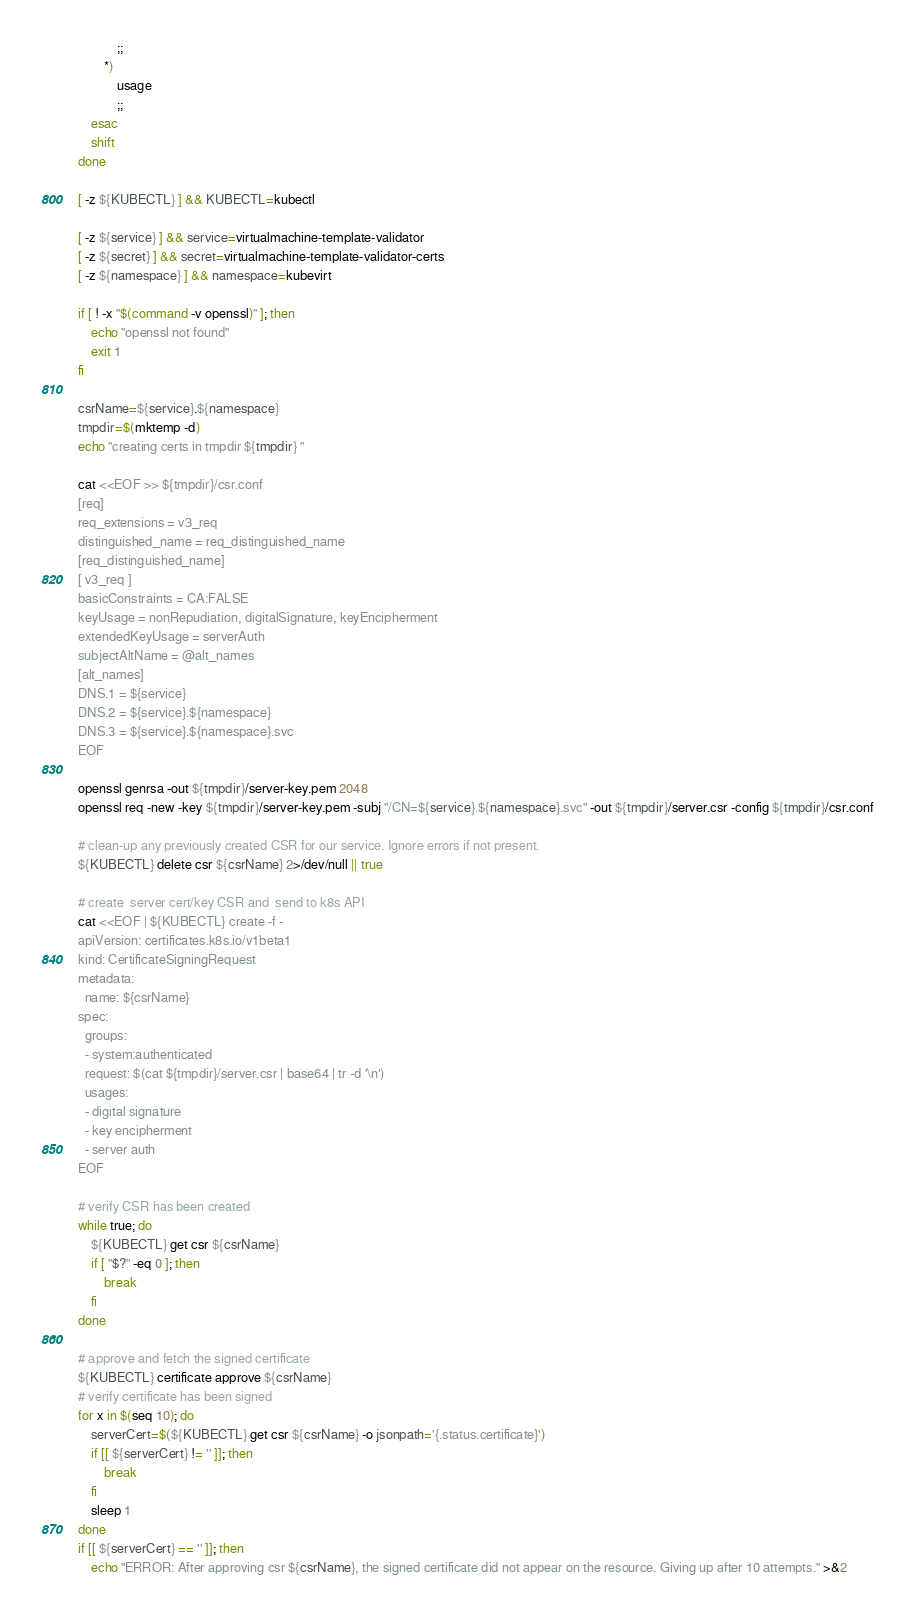Convert code to text. <code><loc_0><loc_0><loc_500><loc_500><_Bash_>            ;;
        *)
            usage
            ;;
    esac
    shift
done

[ -z ${KUBECTL} ] && KUBECTL=kubectl

[ -z ${service} ] && service=virtualmachine-template-validator
[ -z ${secret} ] && secret=virtualmachine-template-validator-certs
[ -z ${namespace} ] && namespace=kubevirt

if [ ! -x "$(command -v openssl)" ]; then
    echo "openssl not found"
    exit 1
fi

csrName=${service}.${namespace}
tmpdir=$(mktemp -d)
echo "creating certs in tmpdir ${tmpdir} "

cat <<EOF >> ${tmpdir}/csr.conf
[req]
req_extensions = v3_req
distinguished_name = req_distinguished_name
[req_distinguished_name]
[ v3_req ]
basicConstraints = CA:FALSE
keyUsage = nonRepudiation, digitalSignature, keyEncipherment
extendedKeyUsage = serverAuth
subjectAltName = @alt_names
[alt_names]
DNS.1 = ${service}
DNS.2 = ${service}.${namespace}
DNS.3 = ${service}.${namespace}.svc
EOF

openssl genrsa -out ${tmpdir}/server-key.pem 2048
openssl req -new -key ${tmpdir}/server-key.pem -subj "/CN=${service}.${namespace}.svc" -out ${tmpdir}/server.csr -config ${tmpdir}/csr.conf

# clean-up any previously created CSR for our service. Ignore errors if not present.
${KUBECTL} delete csr ${csrName} 2>/dev/null || true

# create  server cert/key CSR and  send to k8s API
cat <<EOF | ${KUBECTL} create -f -
apiVersion: certificates.k8s.io/v1beta1
kind: CertificateSigningRequest
metadata:
  name: ${csrName}
spec:
  groups:
  - system:authenticated
  request: $(cat ${tmpdir}/server.csr | base64 | tr -d '\n')
  usages:
  - digital signature
  - key encipherment
  - server auth
EOF

# verify CSR has been created
while true; do
    ${KUBECTL} get csr ${csrName}
    if [ "$?" -eq 0 ]; then
        break
    fi
done

# approve and fetch the signed certificate
${KUBECTL} certificate approve ${csrName}
# verify certificate has been signed
for x in $(seq 10); do
    serverCert=$(${KUBECTL} get csr ${csrName} -o jsonpath='{.status.certificate}')
    if [[ ${serverCert} != '' ]]; then
        break
    fi
    sleep 1
done
if [[ ${serverCert} == '' ]]; then
    echo "ERROR: After approving csr ${csrName}, the signed certificate did not appear on the resource. Giving up after 10 attempts." >&2</code> 